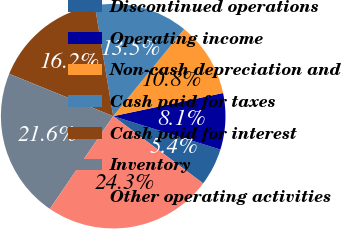<chart> <loc_0><loc_0><loc_500><loc_500><pie_chart><fcel>Discontinued operations<fcel>Operating income<fcel>Non-cash depreciation and<fcel>Cash paid for taxes<fcel>Cash paid for interest<fcel>Inventory<fcel>Other operating activities<nl><fcel>5.41%<fcel>8.11%<fcel>10.81%<fcel>13.51%<fcel>16.22%<fcel>21.62%<fcel>24.32%<nl></chart> 